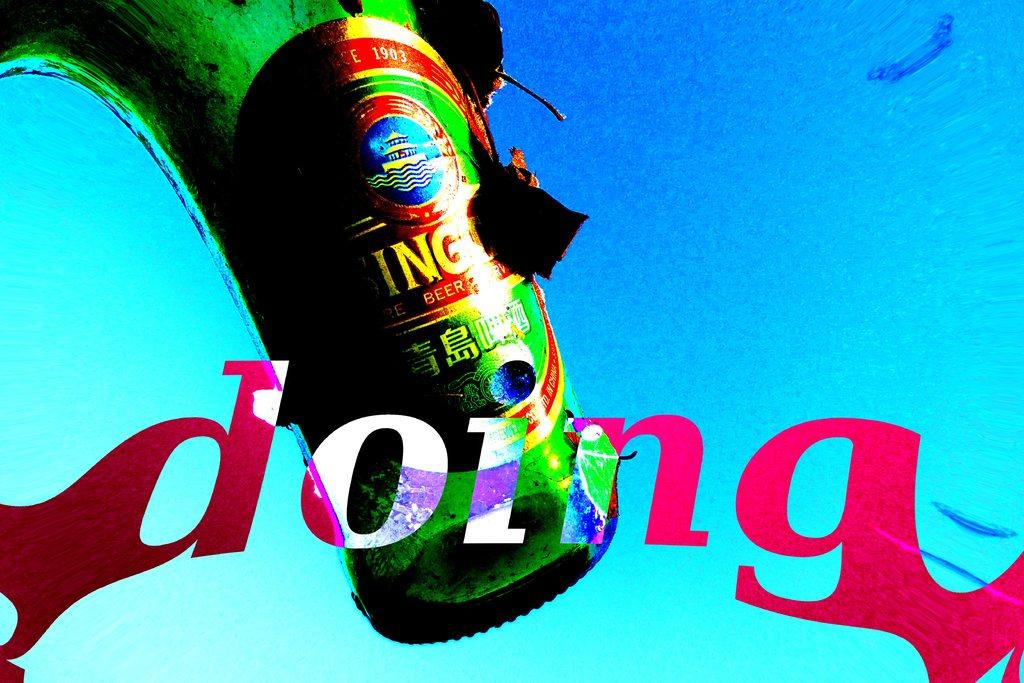What is the color of the object in the image? There is a green color thing in the image. Are there any words or letters visible in the image? Yes, there is writing at a few places in the image. What color is the background of the image? The background of the image is blue. How many women are stretching in the image? There are no women or stretching activities present in the image. 